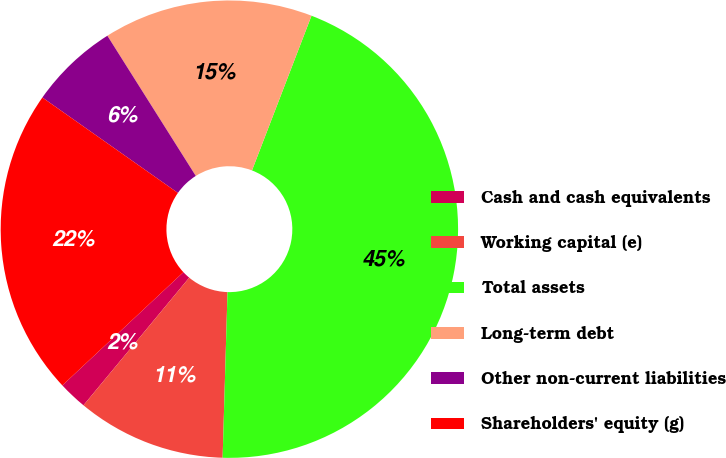Convert chart to OTSL. <chart><loc_0><loc_0><loc_500><loc_500><pie_chart><fcel>Cash and cash equivalents<fcel>Working capital (e)<fcel>Total assets<fcel>Long-term debt<fcel>Other non-current liabilities<fcel>Shareholders' equity (g)<nl><fcel>2.02%<fcel>10.54%<fcel>44.62%<fcel>14.8%<fcel>6.28%<fcel>21.73%<nl></chart> 